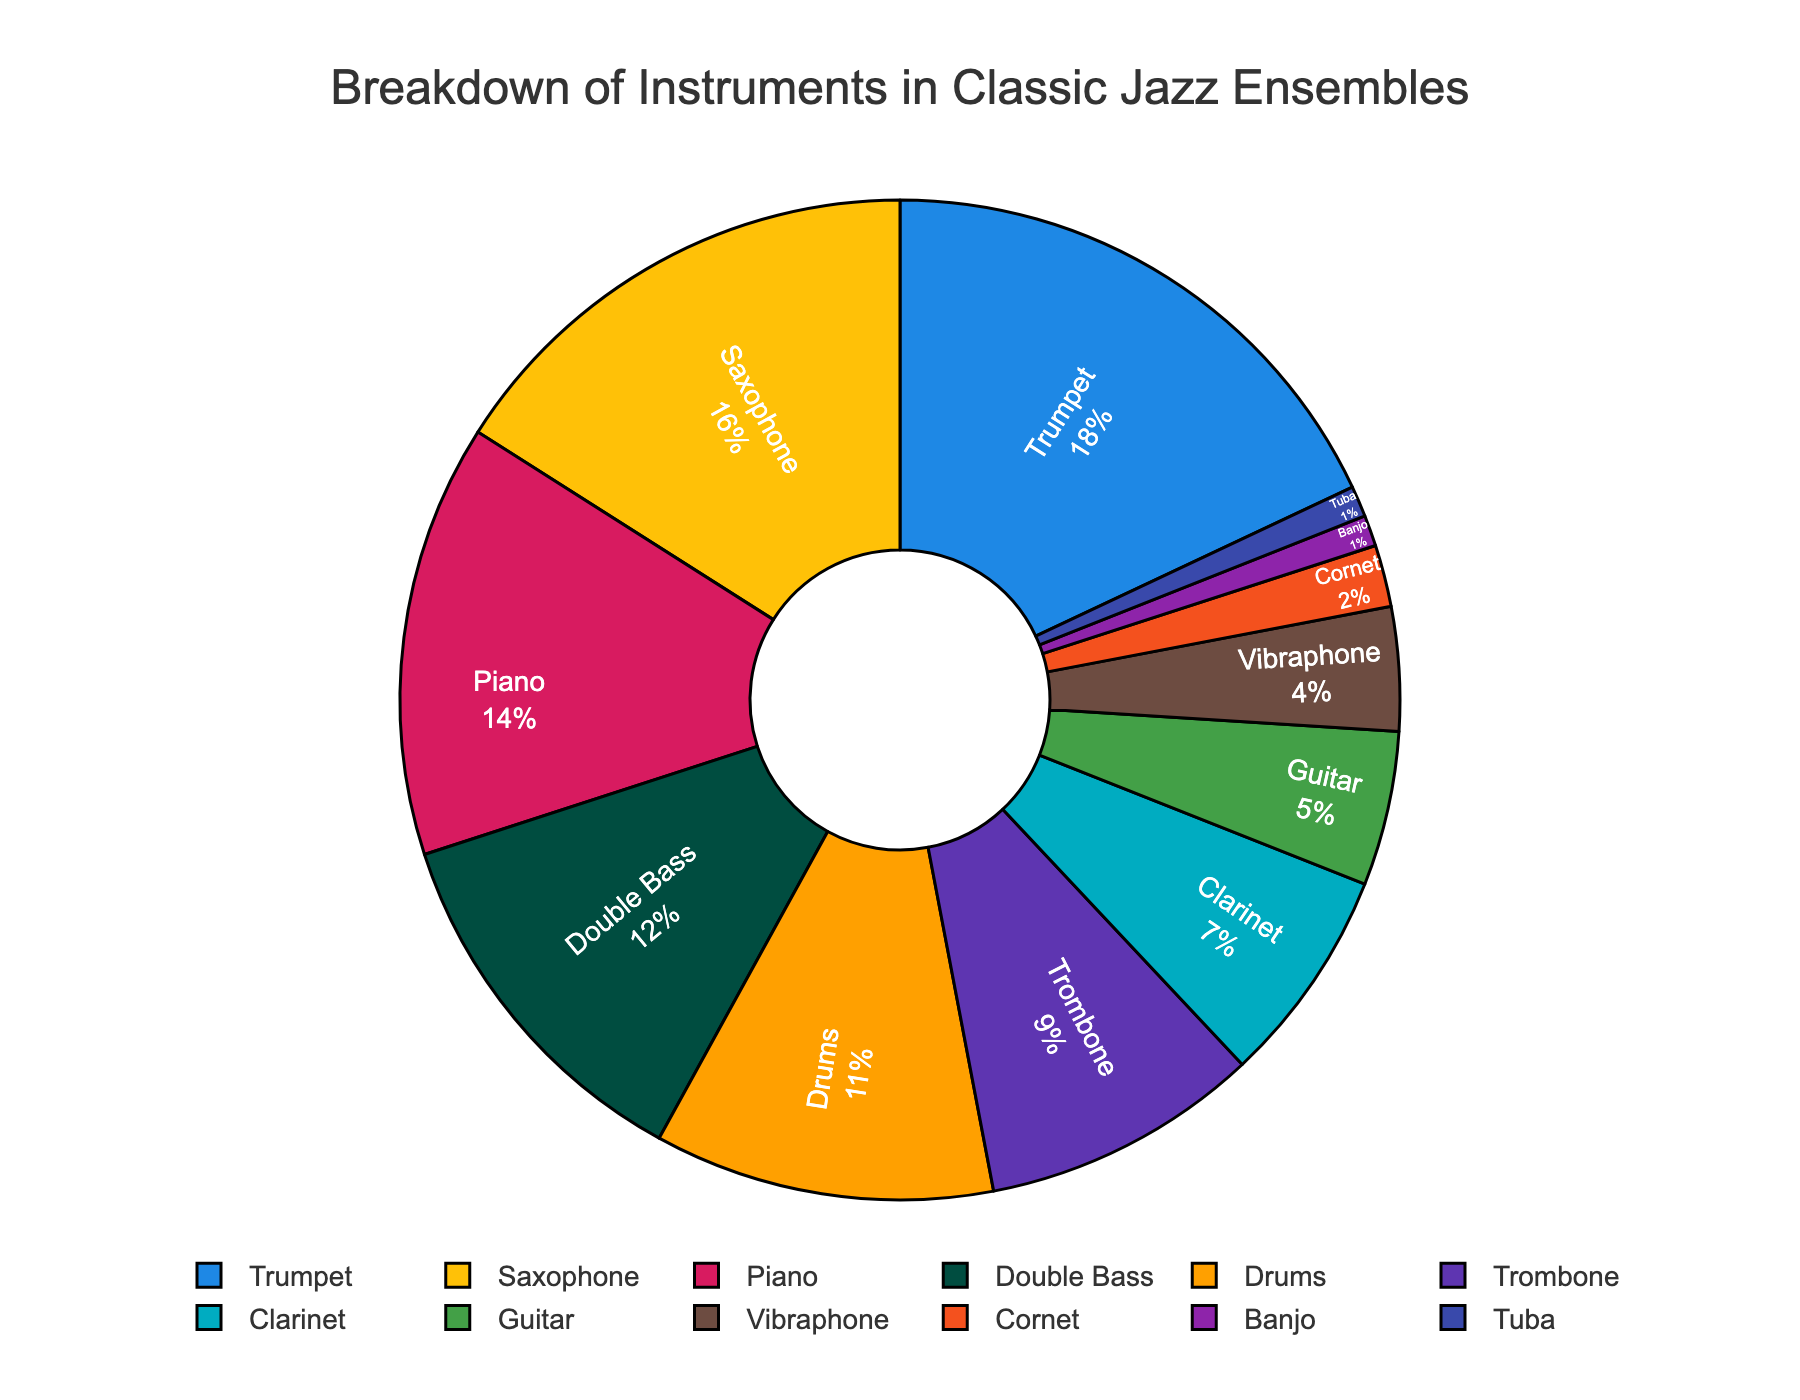Which instrument has the highest percentage in classic jazz ensembles? By inspecting the chart, the segment corresponding to "Trumpet" is the largest, with a percentage label of 18%.
Answer: Trumpet What percentage of classic jazz ensembles use the Saxophone? The chart segment for "Saxophone" has a label indicating the percentage, which is 16%.
Answer: 16% How much more common is the Trumpet compared to the Trombone? The Trumpet is labeled as 18% and the Trombone as 9%. Subtract the Trombone's percentage from the Trumpet's percentage: 18% - 9% = 9%.
Answer: 9% Which instrument is the least used in classic jazz ensembles, and what is its percentage? The smallest segments on the pie chart are labeled "Banjo" and "Tuba", each at 1%.
Answer: Banjo and Tuba, 1% Combine the percentages of the Piano and Double Bass. What is the total percentage? The Piano percentages are labeled as 14% and the Double Bass as 12%. Adding these together: 14% + 12% = 26%.
Answer: 26% Is the Drums percentage greater than the Guitar? If so, by how much? The Drum segment is labeled as 11%, and the Guitar as 5%. The difference is 11% - 5% = 6%.
Answer: Yes, by 6% What is the average percentage of the Vibraphone and Cornet? The Vibraphone is labeled as 4% and the Cornet as 2%. Average them: (4% + 2%) / 2 = 3%.
Answer: 3% Which instruments have a percentage lower than 10%? The pie chart labels "Trombone" at 9%, "Clarinet" at 7%, "Guitar" at 5%, "Vibraphone" at 4%, "Cornet" at 2%, "Banjo" at 1%, and "Tuba" at 1%, all lower than 10%.
Answer: Trombone, Clarinet, Guitar, Vibraphone, Cornet, Banjo, Tuba What's the total percentage of all the string instruments together (Double Bass, Guitar, Banjo)? The Double Bass is 12%, Guitar is 5%, and Banjo is 1%. Summing these: 12% + 5% + 1% = 18%.
Answer: 18% How does the color of the Clarinet section visually compare to the Drums section? The Clarinet section is a shade of blue while the Drums section is a shade of dark green.
Answer: Clarinet is blue, Drums is dark green 